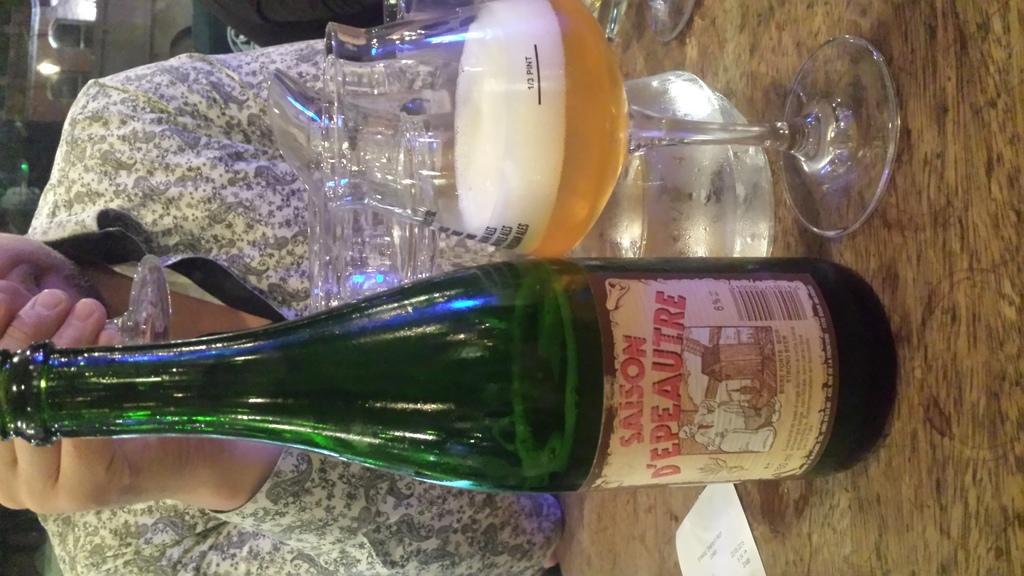What is percentage of alcohol?
Ensure brevity in your answer.  6. What is the first letter of the name of the beer?
Make the answer very short. S. 